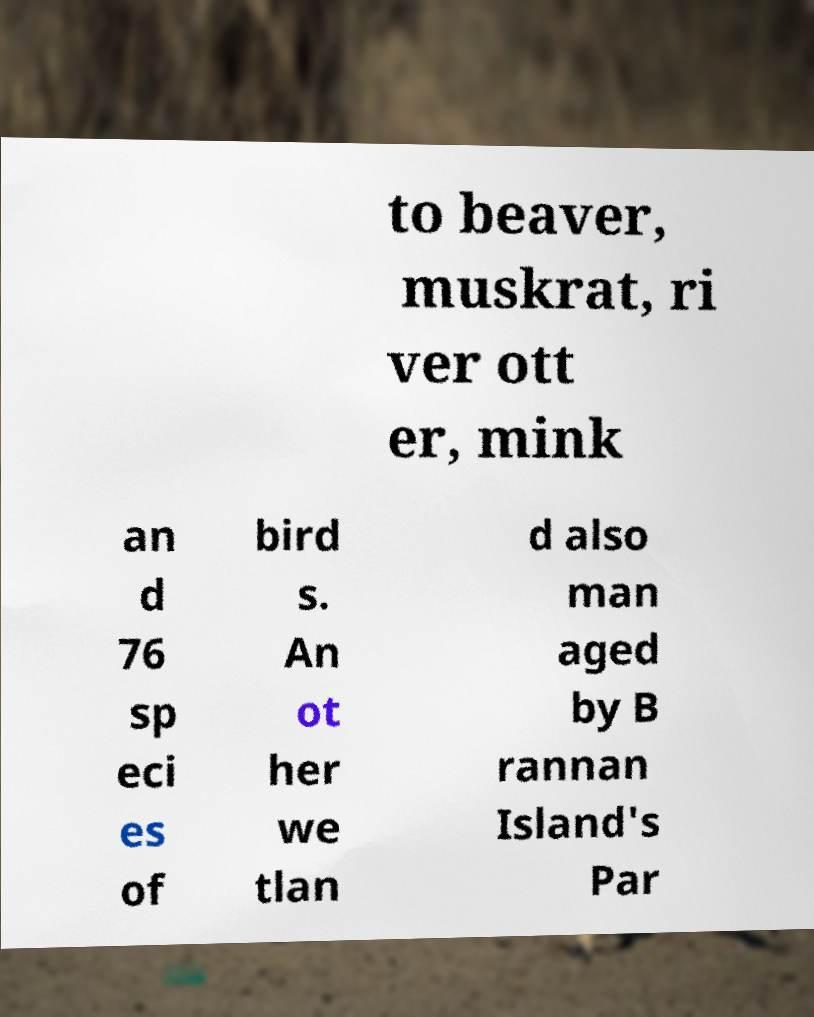Please read and relay the text visible in this image. What does it say? to beaver, muskrat, ri ver ott er, mink an d 76 sp eci es of bird s. An ot her we tlan d also man aged by B rannan Island's Par 